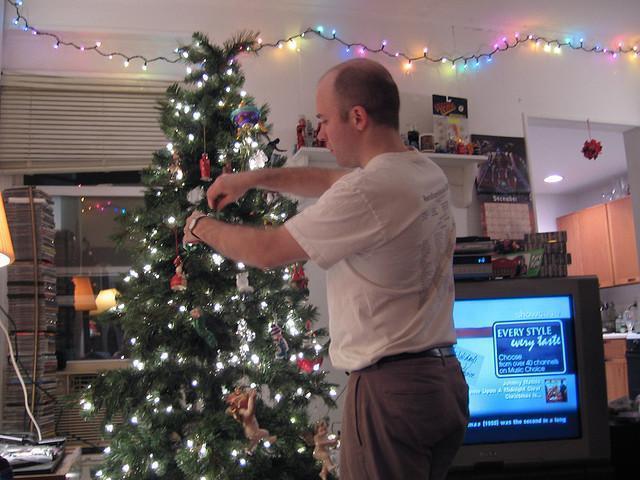How many Christmas tree he is decorating?
Give a very brief answer. 1. 